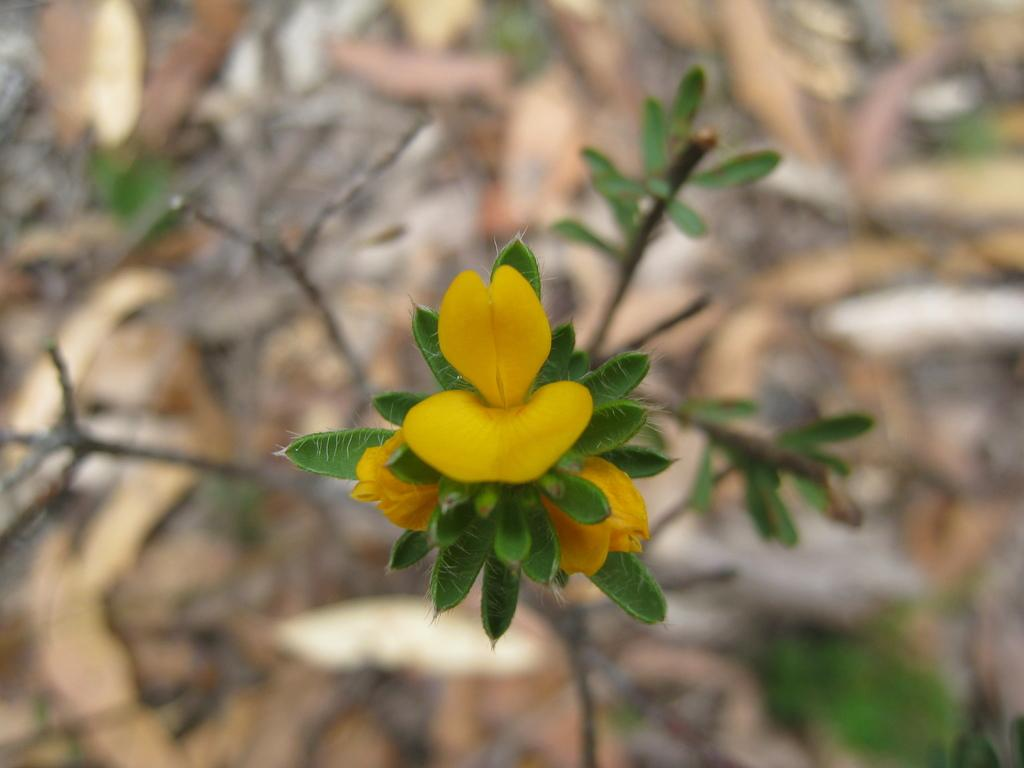What is the main subject in the center of the image? There is a plant in the center of the image. What else can be seen in the image besides the plant? There are flowers in the image. Can you describe the background of the image? The background of the image is blurred. What type of list can be seen hanging on the plant in the image? There is no list present in the image; it features a plant and flowers. How much sugar is visible in the image? There is no sugar present in the image. 